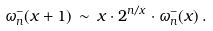<formula> <loc_0><loc_0><loc_500><loc_500>\omega _ { n } ^ { - } ( x + 1 ) \, \sim \, x \cdot 2 ^ { n / x } \cdot \omega _ { n } ^ { - } ( x ) \, .</formula> 